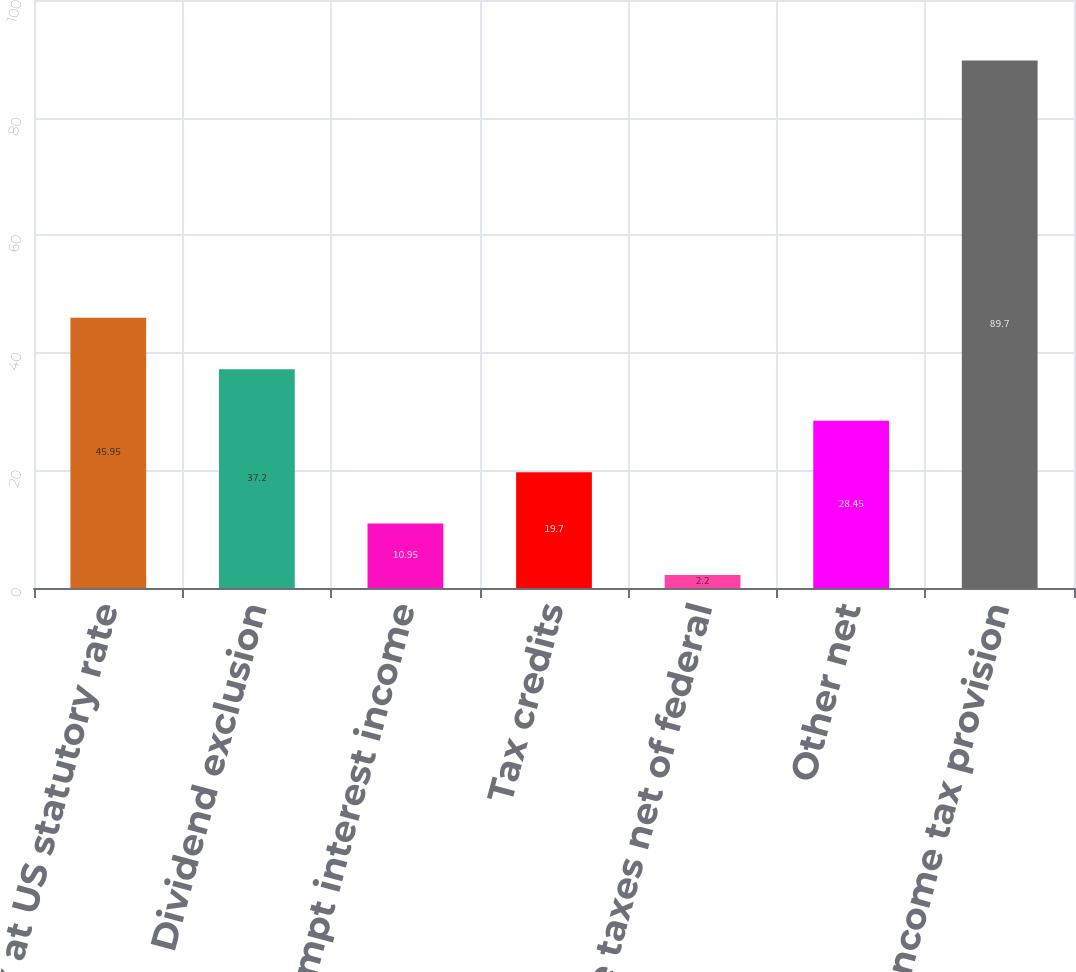Convert chart. <chart><loc_0><loc_0><loc_500><loc_500><bar_chart><fcel>Tax at US statutory rate<fcel>Dividend exclusion<fcel>Tax-exempt interest income<fcel>Tax credits<fcel>State taxes net of federal<fcel>Other net<fcel>Income tax provision<nl><fcel>45.95<fcel>37.2<fcel>10.95<fcel>19.7<fcel>2.2<fcel>28.45<fcel>89.7<nl></chart> 